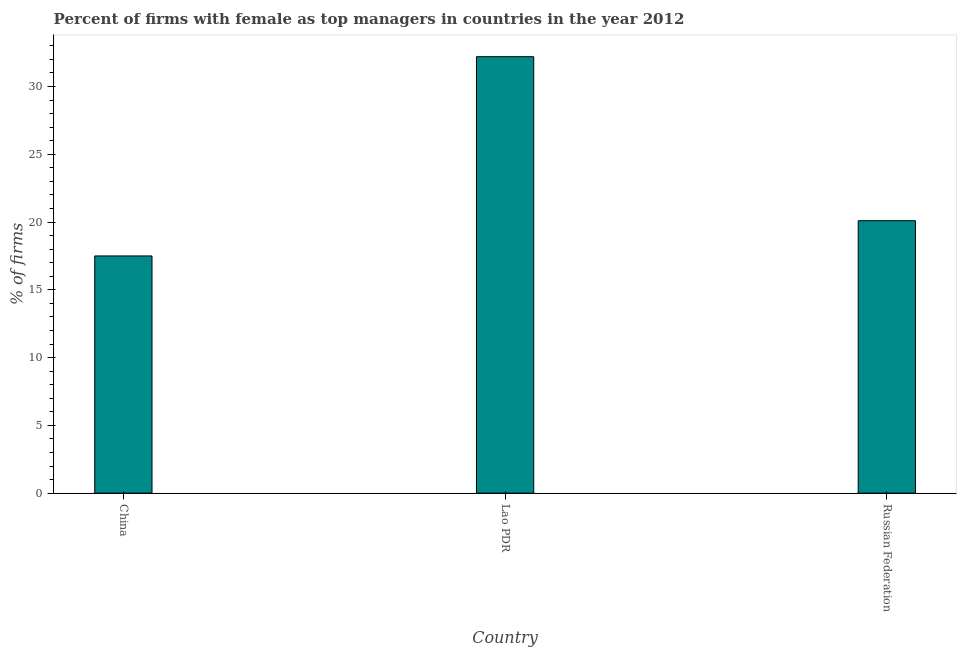Does the graph contain any zero values?
Provide a short and direct response. No. Does the graph contain grids?
Keep it short and to the point. No. What is the title of the graph?
Ensure brevity in your answer.  Percent of firms with female as top managers in countries in the year 2012. What is the label or title of the Y-axis?
Give a very brief answer. % of firms. What is the percentage of firms with female as top manager in Russian Federation?
Ensure brevity in your answer.  20.1. Across all countries, what is the maximum percentage of firms with female as top manager?
Make the answer very short. 32.2. In which country was the percentage of firms with female as top manager maximum?
Your answer should be very brief. Lao PDR. In which country was the percentage of firms with female as top manager minimum?
Keep it short and to the point. China. What is the sum of the percentage of firms with female as top manager?
Offer a terse response. 69.8. What is the average percentage of firms with female as top manager per country?
Ensure brevity in your answer.  23.27. What is the median percentage of firms with female as top manager?
Provide a succinct answer. 20.1. What is the ratio of the percentage of firms with female as top manager in China to that in Russian Federation?
Ensure brevity in your answer.  0.87. Is the percentage of firms with female as top manager in China less than that in Lao PDR?
Your answer should be compact. Yes. What is the % of firms of China?
Ensure brevity in your answer.  17.5. What is the % of firms in Lao PDR?
Offer a terse response. 32.2. What is the % of firms of Russian Federation?
Your answer should be compact. 20.1. What is the difference between the % of firms in China and Lao PDR?
Offer a terse response. -14.7. What is the difference between the % of firms in China and Russian Federation?
Your answer should be very brief. -2.6. What is the ratio of the % of firms in China to that in Lao PDR?
Offer a very short reply. 0.54. What is the ratio of the % of firms in China to that in Russian Federation?
Offer a terse response. 0.87. What is the ratio of the % of firms in Lao PDR to that in Russian Federation?
Keep it short and to the point. 1.6. 